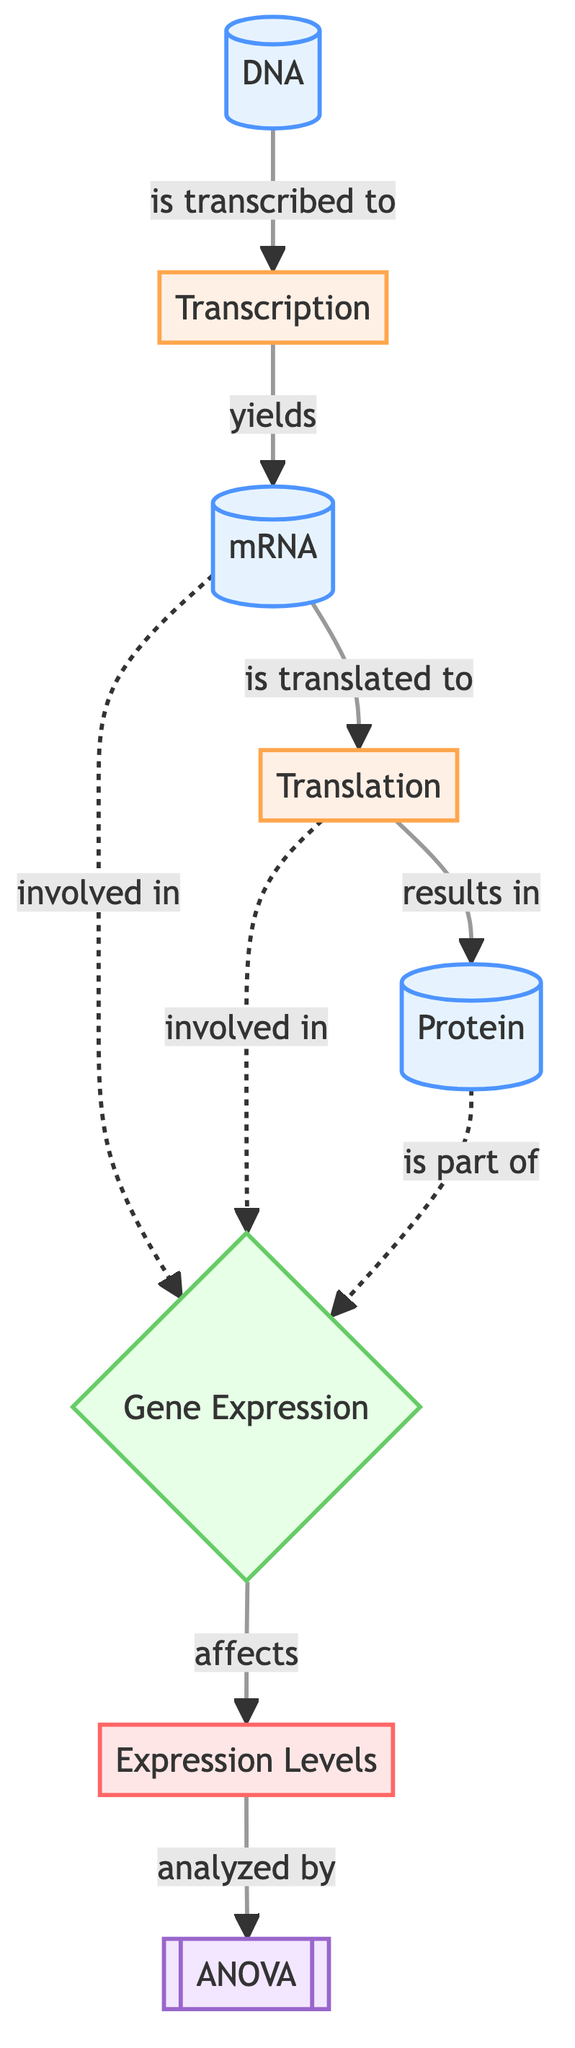What is the starting molecule in the pathway? The diagram shows "DNA" as the first node, indicating it is the starting molecule in the gene expression pathway.
Answer: DNA How many processes are depicted in the diagram? The diagram shows two processes: "Transcription" and "Translation." Counting them gives a total of two processes.
Answer: 2 Which molecule is a product of transcription? The flow from "DNA" to "Transcription," which yields "mRNA," indicates that "mRNA" is the product of transcription.
Answer: mRNA What is the end product of the translation process? Following the arrow from "Translation" leads to "Protein," signifying that "Protein" is the end product of the translation process.
Answer: Protein How many connections does the "Gene Expression" pathway have? The diagram indicates that "Gene Expression" has three connections, shown by arrows coming from "mRNA," "Translation," and "Protein."
Answer: 3 What type of statistical analysis is used on expression levels? The diagram shows "ANOVA" as the statistical analysis applied to the expression levels, clearly indicating the type of analysis.
Answer: ANOVA Which molecule is involved in the gene expression pathway but not a product? The "mRNA" and "Protein" are both involved in the gene expression pathway but only "mRNA" is specifically mentioned as involved.
Answer: mRNA What affects the expression levels according to the diagram? The arrows indicate that the "Gene Expression" pathway affects the "Expression Levels." This establishes the relationship which specifies the effect.
Answer: Gene Expression What role do expression levels play in the analysis shown? The diagram shows that "Expression Levels" are analyzed by "ANOVA," elaborating their role within the analytical framework.
Answer: Analyzed by ANOVA 